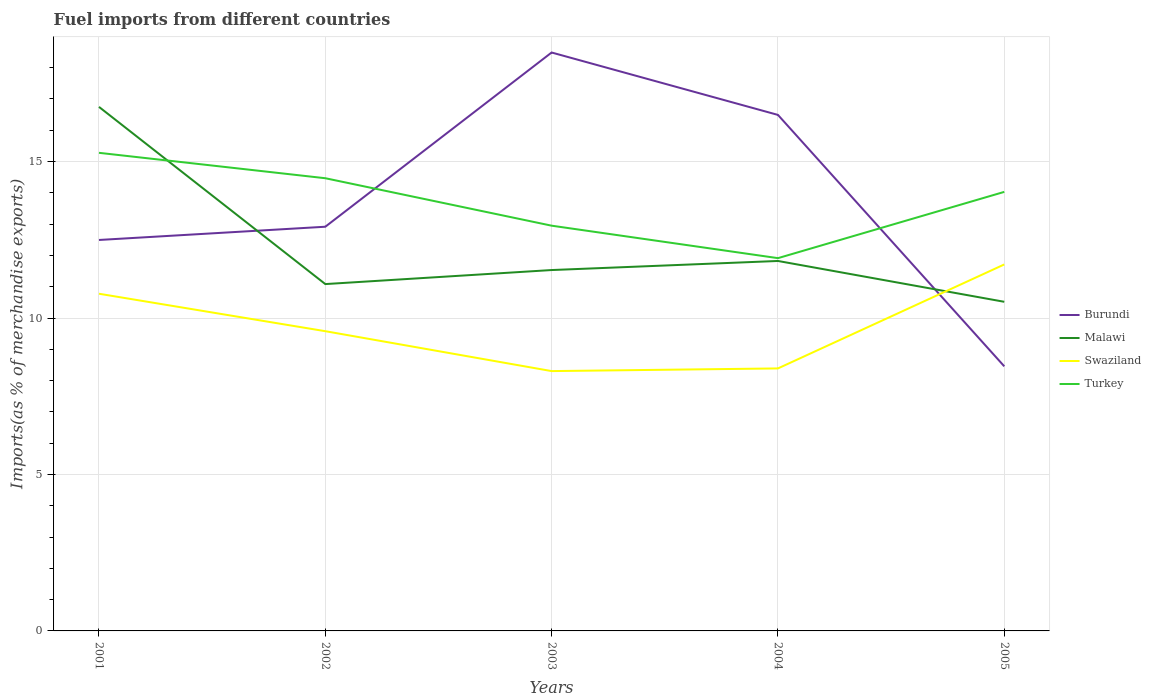How many different coloured lines are there?
Make the answer very short. 4. Is the number of lines equal to the number of legend labels?
Ensure brevity in your answer.  Yes. Across all years, what is the maximum percentage of imports to different countries in Malawi?
Your answer should be very brief. 10.52. In which year was the percentage of imports to different countries in Burundi maximum?
Make the answer very short. 2005. What is the total percentage of imports to different countries in Turkey in the graph?
Your answer should be compact. 1.25. What is the difference between the highest and the second highest percentage of imports to different countries in Burundi?
Make the answer very short. 10.03. Is the percentage of imports to different countries in Swaziland strictly greater than the percentage of imports to different countries in Turkey over the years?
Make the answer very short. Yes. How many lines are there?
Your answer should be compact. 4. How many years are there in the graph?
Your answer should be compact. 5. How are the legend labels stacked?
Offer a very short reply. Vertical. What is the title of the graph?
Your answer should be very brief. Fuel imports from different countries. What is the label or title of the X-axis?
Ensure brevity in your answer.  Years. What is the label or title of the Y-axis?
Give a very brief answer. Imports(as % of merchandise exports). What is the Imports(as % of merchandise exports) of Burundi in 2001?
Provide a short and direct response. 12.49. What is the Imports(as % of merchandise exports) of Malawi in 2001?
Keep it short and to the point. 16.75. What is the Imports(as % of merchandise exports) in Swaziland in 2001?
Ensure brevity in your answer.  10.78. What is the Imports(as % of merchandise exports) in Turkey in 2001?
Offer a terse response. 15.28. What is the Imports(as % of merchandise exports) in Burundi in 2002?
Offer a very short reply. 12.92. What is the Imports(as % of merchandise exports) in Malawi in 2002?
Offer a terse response. 11.08. What is the Imports(as % of merchandise exports) of Swaziland in 2002?
Provide a succinct answer. 9.58. What is the Imports(as % of merchandise exports) of Turkey in 2002?
Provide a short and direct response. 14.47. What is the Imports(as % of merchandise exports) of Burundi in 2003?
Keep it short and to the point. 18.48. What is the Imports(as % of merchandise exports) of Malawi in 2003?
Your answer should be compact. 11.53. What is the Imports(as % of merchandise exports) of Swaziland in 2003?
Your answer should be very brief. 8.3. What is the Imports(as % of merchandise exports) in Turkey in 2003?
Ensure brevity in your answer.  12.95. What is the Imports(as % of merchandise exports) of Burundi in 2004?
Provide a short and direct response. 16.49. What is the Imports(as % of merchandise exports) in Malawi in 2004?
Your answer should be compact. 11.82. What is the Imports(as % of merchandise exports) in Swaziland in 2004?
Your answer should be very brief. 8.39. What is the Imports(as % of merchandise exports) in Turkey in 2004?
Your answer should be very brief. 11.91. What is the Imports(as % of merchandise exports) of Burundi in 2005?
Keep it short and to the point. 8.46. What is the Imports(as % of merchandise exports) in Malawi in 2005?
Your response must be concise. 10.52. What is the Imports(as % of merchandise exports) in Swaziland in 2005?
Provide a succinct answer. 11.71. What is the Imports(as % of merchandise exports) in Turkey in 2005?
Offer a very short reply. 14.03. Across all years, what is the maximum Imports(as % of merchandise exports) in Burundi?
Give a very brief answer. 18.48. Across all years, what is the maximum Imports(as % of merchandise exports) in Malawi?
Your answer should be very brief. 16.75. Across all years, what is the maximum Imports(as % of merchandise exports) in Swaziland?
Provide a short and direct response. 11.71. Across all years, what is the maximum Imports(as % of merchandise exports) of Turkey?
Your answer should be compact. 15.28. Across all years, what is the minimum Imports(as % of merchandise exports) of Burundi?
Offer a very short reply. 8.46. Across all years, what is the minimum Imports(as % of merchandise exports) of Malawi?
Provide a succinct answer. 10.52. Across all years, what is the minimum Imports(as % of merchandise exports) of Swaziland?
Give a very brief answer. 8.3. Across all years, what is the minimum Imports(as % of merchandise exports) of Turkey?
Offer a terse response. 11.91. What is the total Imports(as % of merchandise exports) of Burundi in the graph?
Provide a short and direct response. 68.84. What is the total Imports(as % of merchandise exports) of Malawi in the graph?
Your answer should be compact. 61.7. What is the total Imports(as % of merchandise exports) of Swaziland in the graph?
Your answer should be very brief. 48.76. What is the total Imports(as % of merchandise exports) in Turkey in the graph?
Make the answer very short. 68.64. What is the difference between the Imports(as % of merchandise exports) of Burundi in 2001 and that in 2002?
Your answer should be compact. -0.42. What is the difference between the Imports(as % of merchandise exports) of Malawi in 2001 and that in 2002?
Give a very brief answer. 5.66. What is the difference between the Imports(as % of merchandise exports) in Swaziland in 2001 and that in 2002?
Ensure brevity in your answer.  1.2. What is the difference between the Imports(as % of merchandise exports) in Turkey in 2001 and that in 2002?
Your answer should be compact. 0.81. What is the difference between the Imports(as % of merchandise exports) of Burundi in 2001 and that in 2003?
Offer a terse response. -5.99. What is the difference between the Imports(as % of merchandise exports) in Malawi in 2001 and that in 2003?
Offer a very short reply. 5.21. What is the difference between the Imports(as % of merchandise exports) in Swaziland in 2001 and that in 2003?
Your answer should be very brief. 2.47. What is the difference between the Imports(as % of merchandise exports) of Turkey in 2001 and that in 2003?
Keep it short and to the point. 2.33. What is the difference between the Imports(as % of merchandise exports) of Burundi in 2001 and that in 2004?
Offer a terse response. -4. What is the difference between the Imports(as % of merchandise exports) in Malawi in 2001 and that in 2004?
Keep it short and to the point. 4.92. What is the difference between the Imports(as % of merchandise exports) in Swaziland in 2001 and that in 2004?
Give a very brief answer. 2.39. What is the difference between the Imports(as % of merchandise exports) in Turkey in 2001 and that in 2004?
Offer a terse response. 3.37. What is the difference between the Imports(as % of merchandise exports) of Burundi in 2001 and that in 2005?
Make the answer very short. 4.04. What is the difference between the Imports(as % of merchandise exports) of Malawi in 2001 and that in 2005?
Your answer should be very brief. 6.23. What is the difference between the Imports(as % of merchandise exports) of Swaziland in 2001 and that in 2005?
Your answer should be very brief. -0.94. What is the difference between the Imports(as % of merchandise exports) of Turkey in 2001 and that in 2005?
Make the answer very short. 1.25. What is the difference between the Imports(as % of merchandise exports) of Burundi in 2002 and that in 2003?
Give a very brief answer. -5.57. What is the difference between the Imports(as % of merchandise exports) in Malawi in 2002 and that in 2003?
Provide a succinct answer. -0.45. What is the difference between the Imports(as % of merchandise exports) of Swaziland in 2002 and that in 2003?
Your response must be concise. 1.28. What is the difference between the Imports(as % of merchandise exports) of Turkey in 2002 and that in 2003?
Make the answer very short. 1.52. What is the difference between the Imports(as % of merchandise exports) of Burundi in 2002 and that in 2004?
Provide a short and direct response. -3.57. What is the difference between the Imports(as % of merchandise exports) of Malawi in 2002 and that in 2004?
Make the answer very short. -0.74. What is the difference between the Imports(as % of merchandise exports) of Swaziland in 2002 and that in 2004?
Ensure brevity in your answer.  1.19. What is the difference between the Imports(as % of merchandise exports) in Turkey in 2002 and that in 2004?
Your answer should be very brief. 2.55. What is the difference between the Imports(as % of merchandise exports) in Burundi in 2002 and that in 2005?
Ensure brevity in your answer.  4.46. What is the difference between the Imports(as % of merchandise exports) of Malawi in 2002 and that in 2005?
Your answer should be very brief. 0.57. What is the difference between the Imports(as % of merchandise exports) in Swaziland in 2002 and that in 2005?
Make the answer very short. -2.13. What is the difference between the Imports(as % of merchandise exports) of Turkey in 2002 and that in 2005?
Offer a terse response. 0.44. What is the difference between the Imports(as % of merchandise exports) in Burundi in 2003 and that in 2004?
Make the answer very short. 1.99. What is the difference between the Imports(as % of merchandise exports) of Malawi in 2003 and that in 2004?
Your response must be concise. -0.29. What is the difference between the Imports(as % of merchandise exports) in Swaziland in 2003 and that in 2004?
Your response must be concise. -0.09. What is the difference between the Imports(as % of merchandise exports) of Turkey in 2003 and that in 2004?
Your answer should be compact. 1.04. What is the difference between the Imports(as % of merchandise exports) in Burundi in 2003 and that in 2005?
Offer a terse response. 10.03. What is the difference between the Imports(as % of merchandise exports) in Malawi in 2003 and that in 2005?
Offer a terse response. 1.01. What is the difference between the Imports(as % of merchandise exports) of Swaziland in 2003 and that in 2005?
Provide a short and direct response. -3.41. What is the difference between the Imports(as % of merchandise exports) of Turkey in 2003 and that in 2005?
Provide a succinct answer. -1.08. What is the difference between the Imports(as % of merchandise exports) of Burundi in 2004 and that in 2005?
Your response must be concise. 8.03. What is the difference between the Imports(as % of merchandise exports) in Malawi in 2004 and that in 2005?
Your response must be concise. 1.3. What is the difference between the Imports(as % of merchandise exports) of Swaziland in 2004 and that in 2005?
Your response must be concise. -3.32. What is the difference between the Imports(as % of merchandise exports) of Turkey in 2004 and that in 2005?
Provide a short and direct response. -2.12. What is the difference between the Imports(as % of merchandise exports) in Burundi in 2001 and the Imports(as % of merchandise exports) in Malawi in 2002?
Offer a terse response. 1.41. What is the difference between the Imports(as % of merchandise exports) in Burundi in 2001 and the Imports(as % of merchandise exports) in Swaziland in 2002?
Your answer should be compact. 2.92. What is the difference between the Imports(as % of merchandise exports) of Burundi in 2001 and the Imports(as % of merchandise exports) of Turkey in 2002?
Offer a terse response. -1.97. What is the difference between the Imports(as % of merchandise exports) of Malawi in 2001 and the Imports(as % of merchandise exports) of Swaziland in 2002?
Make the answer very short. 7.17. What is the difference between the Imports(as % of merchandise exports) of Malawi in 2001 and the Imports(as % of merchandise exports) of Turkey in 2002?
Offer a terse response. 2.28. What is the difference between the Imports(as % of merchandise exports) of Swaziland in 2001 and the Imports(as % of merchandise exports) of Turkey in 2002?
Your response must be concise. -3.69. What is the difference between the Imports(as % of merchandise exports) in Burundi in 2001 and the Imports(as % of merchandise exports) in Malawi in 2003?
Keep it short and to the point. 0.96. What is the difference between the Imports(as % of merchandise exports) of Burundi in 2001 and the Imports(as % of merchandise exports) of Swaziland in 2003?
Your answer should be very brief. 4.19. What is the difference between the Imports(as % of merchandise exports) of Burundi in 2001 and the Imports(as % of merchandise exports) of Turkey in 2003?
Offer a terse response. -0.46. What is the difference between the Imports(as % of merchandise exports) in Malawi in 2001 and the Imports(as % of merchandise exports) in Swaziland in 2003?
Make the answer very short. 8.44. What is the difference between the Imports(as % of merchandise exports) in Malawi in 2001 and the Imports(as % of merchandise exports) in Turkey in 2003?
Your response must be concise. 3.8. What is the difference between the Imports(as % of merchandise exports) in Swaziland in 2001 and the Imports(as % of merchandise exports) in Turkey in 2003?
Your answer should be compact. -2.17. What is the difference between the Imports(as % of merchandise exports) in Burundi in 2001 and the Imports(as % of merchandise exports) in Malawi in 2004?
Offer a terse response. 0.67. What is the difference between the Imports(as % of merchandise exports) of Burundi in 2001 and the Imports(as % of merchandise exports) of Swaziland in 2004?
Provide a short and direct response. 4.11. What is the difference between the Imports(as % of merchandise exports) of Burundi in 2001 and the Imports(as % of merchandise exports) of Turkey in 2004?
Give a very brief answer. 0.58. What is the difference between the Imports(as % of merchandise exports) in Malawi in 2001 and the Imports(as % of merchandise exports) in Swaziland in 2004?
Your answer should be very brief. 8.36. What is the difference between the Imports(as % of merchandise exports) in Malawi in 2001 and the Imports(as % of merchandise exports) in Turkey in 2004?
Offer a terse response. 4.83. What is the difference between the Imports(as % of merchandise exports) of Swaziland in 2001 and the Imports(as % of merchandise exports) of Turkey in 2004?
Provide a succinct answer. -1.14. What is the difference between the Imports(as % of merchandise exports) of Burundi in 2001 and the Imports(as % of merchandise exports) of Malawi in 2005?
Offer a terse response. 1.98. What is the difference between the Imports(as % of merchandise exports) of Burundi in 2001 and the Imports(as % of merchandise exports) of Swaziland in 2005?
Your response must be concise. 0.78. What is the difference between the Imports(as % of merchandise exports) in Burundi in 2001 and the Imports(as % of merchandise exports) in Turkey in 2005?
Your answer should be compact. -1.54. What is the difference between the Imports(as % of merchandise exports) of Malawi in 2001 and the Imports(as % of merchandise exports) of Swaziland in 2005?
Offer a very short reply. 5.04. What is the difference between the Imports(as % of merchandise exports) of Malawi in 2001 and the Imports(as % of merchandise exports) of Turkey in 2005?
Provide a short and direct response. 2.72. What is the difference between the Imports(as % of merchandise exports) of Swaziland in 2001 and the Imports(as % of merchandise exports) of Turkey in 2005?
Your response must be concise. -3.26. What is the difference between the Imports(as % of merchandise exports) in Burundi in 2002 and the Imports(as % of merchandise exports) in Malawi in 2003?
Make the answer very short. 1.38. What is the difference between the Imports(as % of merchandise exports) in Burundi in 2002 and the Imports(as % of merchandise exports) in Swaziland in 2003?
Offer a terse response. 4.61. What is the difference between the Imports(as % of merchandise exports) of Burundi in 2002 and the Imports(as % of merchandise exports) of Turkey in 2003?
Ensure brevity in your answer.  -0.03. What is the difference between the Imports(as % of merchandise exports) of Malawi in 2002 and the Imports(as % of merchandise exports) of Swaziland in 2003?
Your answer should be compact. 2.78. What is the difference between the Imports(as % of merchandise exports) of Malawi in 2002 and the Imports(as % of merchandise exports) of Turkey in 2003?
Offer a very short reply. -1.87. What is the difference between the Imports(as % of merchandise exports) in Swaziland in 2002 and the Imports(as % of merchandise exports) in Turkey in 2003?
Make the answer very short. -3.37. What is the difference between the Imports(as % of merchandise exports) in Burundi in 2002 and the Imports(as % of merchandise exports) in Malawi in 2004?
Keep it short and to the point. 1.09. What is the difference between the Imports(as % of merchandise exports) in Burundi in 2002 and the Imports(as % of merchandise exports) in Swaziland in 2004?
Offer a very short reply. 4.53. What is the difference between the Imports(as % of merchandise exports) in Burundi in 2002 and the Imports(as % of merchandise exports) in Turkey in 2004?
Provide a short and direct response. 1. What is the difference between the Imports(as % of merchandise exports) of Malawi in 2002 and the Imports(as % of merchandise exports) of Swaziland in 2004?
Ensure brevity in your answer.  2.7. What is the difference between the Imports(as % of merchandise exports) of Malawi in 2002 and the Imports(as % of merchandise exports) of Turkey in 2004?
Keep it short and to the point. -0.83. What is the difference between the Imports(as % of merchandise exports) in Swaziland in 2002 and the Imports(as % of merchandise exports) in Turkey in 2004?
Provide a succinct answer. -2.33. What is the difference between the Imports(as % of merchandise exports) of Burundi in 2002 and the Imports(as % of merchandise exports) of Malawi in 2005?
Keep it short and to the point. 2.4. What is the difference between the Imports(as % of merchandise exports) of Burundi in 2002 and the Imports(as % of merchandise exports) of Swaziland in 2005?
Provide a succinct answer. 1.21. What is the difference between the Imports(as % of merchandise exports) of Burundi in 2002 and the Imports(as % of merchandise exports) of Turkey in 2005?
Ensure brevity in your answer.  -1.11. What is the difference between the Imports(as % of merchandise exports) of Malawi in 2002 and the Imports(as % of merchandise exports) of Swaziland in 2005?
Give a very brief answer. -0.63. What is the difference between the Imports(as % of merchandise exports) of Malawi in 2002 and the Imports(as % of merchandise exports) of Turkey in 2005?
Make the answer very short. -2.95. What is the difference between the Imports(as % of merchandise exports) in Swaziland in 2002 and the Imports(as % of merchandise exports) in Turkey in 2005?
Your response must be concise. -4.45. What is the difference between the Imports(as % of merchandise exports) in Burundi in 2003 and the Imports(as % of merchandise exports) in Malawi in 2004?
Ensure brevity in your answer.  6.66. What is the difference between the Imports(as % of merchandise exports) in Burundi in 2003 and the Imports(as % of merchandise exports) in Swaziland in 2004?
Keep it short and to the point. 10.1. What is the difference between the Imports(as % of merchandise exports) in Burundi in 2003 and the Imports(as % of merchandise exports) in Turkey in 2004?
Keep it short and to the point. 6.57. What is the difference between the Imports(as % of merchandise exports) in Malawi in 2003 and the Imports(as % of merchandise exports) in Swaziland in 2004?
Give a very brief answer. 3.14. What is the difference between the Imports(as % of merchandise exports) of Malawi in 2003 and the Imports(as % of merchandise exports) of Turkey in 2004?
Ensure brevity in your answer.  -0.38. What is the difference between the Imports(as % of merchandise exports) in Swaziland in 2003 and the Imports(as % of merchandise exports) in Turkey in 2004?
Offer a terse response. -3.61. What is the difference between the Imports(as % of merchandise exports) of Burundi in 2003 and the Imports(as % of merchandise exports) of Malawi in 2005?
Provide a succinct answer. 7.97. What is the difference between the Imports(as % of merchandise exports) in Burundi in 2003 and the Imports(as % of merchandise exports) in Swaziland in 2005?
Your answer should be compact. 6.77. What is the difference between the Imports(as % of merchandise exports) in Burundi in 2003 and the Imports(as % of merchandise exports) in Turkey in 2005?
Offer a very short reply. 4.45. What is the difference between the Imports(as % of merchandise exports) of Malawi in 2003 and the Imports(as % of merchandise exports) of Swaziland in 2005?
Your answer should be very brief. -0.18. What is the difference between the Imports(as % of merchandise exports) of Malawi in 2003 and the Imports(as % of merchandise exports) of Turkey in 2005?
Offer a very short reply. -2.5. What is the difference between the Imports(as % of merchandise exports) in Swaziland in 2003 and the Imports(as % of merchandise exports) in Turkey in 2005?
Keep it short and to the point. -5.73. What is the difference between the Imports(as % of merchandise exports) of Burundi in 2004 and the Imports(as % of merchandise exports) of Malawi in 2005?
Ensure brevity in your answer.  5.97. What is the difference between the Imports(as % of merchandise exports) in Burundi in 2004 and the Imports(as % of merchandise exports) in Swaziland in 2005?
Keep it short and to the point. 4.78. What is the difference between the Imports(as % of merchandise exports) of Burundi in 2004 and the Imports(as % of merchandise exports) of Turkey in 2005?
Provide a short and direct response. 2.46. What is the difference between the Imports(as % of merchandise exports) in Malawi in 2004 and the Imports(as % of merchandise exports) in Swaziland in 2005?
Ensure brevity in your answer.  0.11. What is the difference between the Imports(as % of merchandise exports) in Malawi in 2004 and the Imports(as % of merchandise exports) in Turkey in 2005?
Give a very brief answer. -2.21. What is the difference between the Imports(as % of merchandise exports) in Swaziland in 2004 and the Imports(as % of merchandise exports) in Turkey in 2005?
Provide a succinct answer. -5.64. What is the average Imports(as % of merchandise exports) in Burundi per year?
Keep it short and to the point. 13.77. What is the average Imports(as % of merchandise exports) in Malawi per year?
Offer a terse response. 12.34. What is the average Imports(as % of merchandise exports) of Swaziland per year?
Offer a terse response. 9.75. What is the average Imports(as % of merchandise exports) of Turkey per year?
Give a very brief answer. 13.73. In the year 2001, what is the difference between the Imports(as % of merchandise exports) in Burundi and Imports(as % of merchandise exports) in Malawi?
Your answer should be very brief. -4.25. In the year 2001, what is the difference between the Imports(as % of merchandise exports) in Burundi and Imports(as % of merchandise exports) in Swaziland?
Your answer should be very brief. 1.72. In the year 2001, what is the difference between the Imports(as % of merchandise exports) of Burundi and Imports(as % of merchandise exports) of Turkey?
Ensure brevity in your answer.  -2.78. In the year 2001, what is the difference between the Imports(as % of merchandise exports) in Malawi and Imports(as % of merchandise exports) in Swaziland?
Keep it short and to the point. 5.97. In the year 2001, what is the difference between the Imports(as % of merchandise exports) in Malawi and Imports(as % of merchandise exports) in Turkey?
Ensure brevity in your answer.  1.47. In the year 2001, what is the difference between the Imports(as % of merchandise exports) in Swaziland and Imports(as % of merchandise exports) in Turkey?
Give a very brief answer. -4.5. In the year 2002, what is the difference between the Imports(as % of merchandise exports) of Burundi and Imports(as % of merchandise exports) of Malawi?
Your answer should be very brief. 1.83. In the year 2002, what is the difference between the Imports(as % of merchandise exports) of Burundi and Imports(as % of merchandise exports) of Swaziland?
Provide a short and direct response. 3.34. In the year 2002, what is the difference between the Imports(as % of merchandise exports) of Burundi and Imports(as % of merchandise exports) of Turkey?
Your answer should be compact. -1.55. In the year 2002, what is the difference between the Imports(as % of merchandise exports) in Malawi and Imports(as % of merchandise exports) in Swaziland?
Give a very brief answer. 1.51. In the year 2002, what is the difference between the Imports(as % of merchandise exports) of Malawi and Imports(as % of merchandise exports) of Turkey?
Your answer should be very brief. -3.38. In the year 2002, what is the difference between the Imports(as % of merchandise exports) in Swaziland and Imports(as % of merchandise exports) in Turkey?
Make the answer very short. -4.89. In the year 2003, what is the difference between the Imports(as % of merchandise exports) in Burundi and Imports(as % of merchandise exports) in Malawi?
Give a very brief answer. 6.95. In the year 2003, what is the difference between the Imports(as % of merchandise exports) of Burundi and Imports(as % of merchandise exports) of Swaziland?
Your response must be concise. 10.18. In the year 2003, what is the difference between the Imports(as % of merchandise exports) in Burundi and Imports(as % of merchandise exports) in Turkey?
Keep it short and to the point. 5.53. In the year 2003, what is the difference between the Imports(as % of merchandise exports) of Malawi and Imports(as % of merchandise exports) of Swaziland?
Offer a very short reply. 3.23. In the year 2003, what is the difference between the Imports(as % of merchandise exports) in Malawi and Imports(as % of merchandise exports) in Turkey?
Ensure brevity in your answer.  -1.42. In the year 2003, what is the difference between the Imports(as % of merchandise exports) of Swaziland and Imports(as % of merchandise exports) of Turkey?
Make the answer very short. -4.65. In the year 2004, what is the difference between the Imports(as % of merchandise exports) in Burundi and Imports(as % of merchandise exports) in Malawi?
Make the answer very short. 4.67. In the year 2004, what is the difference between the Imports(as % of merchandise exports) of Burundi and Imports(as % of merchandise exports) of Swaziland?
Your answer should be very brief. 8.1. In the year 2004, what is the difference between the Imports(as % of merchandise exports) of Burundi and Imports(as % of merchandise exports) of Turkey?
Offer a terse response. 4.58. In the year 2004, what is the difference between the Imports(as % of merchandise exports) in Malawi and Imports(as % of merchandise exports) in Swaziland?
Make the answer very short. 3.43. In the year 2004, what is the difference between the Imports(as % of merchandise exports) of Malawi and Imports(as % of merchandise exports) of Turkey?
Keep it short and to the point. -0.09. In the year 2004, what is the difference between the Imports(as % of merchandise exports) in Swaziland and Imports(as % of merchandise exports) in Turkey?
Your response must be concise. -3.52. In the year 2005, what is the difference between the Imports(as % of merchandise exports) in Burundi and Imports(as % of merchandise exports) in Malawi?
Your answer should be compact. -2.06. In the year 2005, what is the difference between the Imports(as % of merchandise exports) of Burundi and Imports(as % of merchandise exports) of Swaziland?
Your response must be concise. -3.26. In the year 2005, what is the difference between the Imports(as % of merchandise exports) in Burundi and Imports(as % of merchandise exports) in Turkey?
Provide a short and direct response. -5.58. In the year 2005, what is the difference between the Imports(as % of merchandise exports) of Malawi and Imports(as % of merchandise exports) of Swaziland?
Make the answer very short. -1.19. In the year 2005, what is the difference between the Imports(as % of merchandise exports) in Malawi and Imports(as % of merchandise exports) in Turkey?
Provide a succinct answer. -3.51. In the year 2005, what is the difference between the Imports(as % of merchandise exports) of Swaziland and Imports(as % of merchandise exports) of Turkey?
Keep it short and to the point. -2.32. What is the ratio of the Imports(as % of merchandise exports) of Burundi in 2001 to that in 2002?
Ensure brevity in your answer.  0.97. What is the ratio of the Imports(as % of merchandise exports) in Malawi in 2001 to that in 2002?
Your answer should be very brief. 1.51. What is the ratio of the Imports(as % of merchandise exports) in Swaziland in 2001 to that in 2002?
Give a very brief answer. 1.12. What is the ratio of the Imports(as % of merchandise exports) in Turkey in 2001 to that in 2002?
Provide a short and direct response. 1.06. What is the ratio of the Imports(as % of merchandise exports) of Burundi in 2001 to that in 2003?
Provide a succinct answer. 0.68. What is the ratio of the Imports(as % of merchandise exports) of Malawi in 2001 to that in 2003?
Provide a short and direct response. 1.45. What is the ratio of the Imports(as % of merchandise exports) in Swaziland in 2001 to that in 2003?
Your response must be concise. 1.3. What is the ratio of the Imports(as % of merchandise exports) of Turkey in 2001 to that in 2003?
Offer a terse response. 1.18. What is the ratio of the Imports(as % of merchandise exports) in Burundi in 2001 to that in 2004?
Ensure brevity in your answer.  0.76. What is the ratio of the Imports(as % of merchandise exports) in Malawi in 2001 to that in 2004?
Give a very brief answer. 1.42. What is the ratio of the Imports(as % of merchandise exports) in Swaziland in 2001 to that in 2004?
Offer a very short reply. 1.28. What is the ratio of the Imports(as % of merchandise exports) of Turkey in 2001 to that in 2004?
Your answer should be very brief. 1.28. What is the ratio of the Imports(as % of merchandise exports) of Burundi in 2001 to that in 2005?
Make the answer very short. 1.48. What is the ratio of the Imports(as % of merchandise exports) in Malawi in 2001 to that in 2005?
Offer a terse response. 1.59. What is the ratio of the Imports(as % of merchandise exports) in Swaziland in 2001 to that in 2005?
Give a very brief answer. 0.92. What is the ratio of the Imports(as % of merchandise exports) in Turkey in 2001 to that in 2005?
Make the answer very short. 1.09. What is the ratio of the Imports(as % of merchandise exports) of Burundi in 2002 to that in 2003?
Offer a very short reply. 0.7. What is the ratio of the Imports(as % of merchandise exports) of Malawi in 2002 to that in 2003?
Offer a very short reply. 0.96. What is the ratio of the Imports(as % of merchandise exports) in Swaziland in 2002 to that in 2003?
Provide a succinct answer. 1.15. What is the ratio of the Imports(as % of merchandise exports) of Turkey in 2002 to that in 2003?
Make the answer very short. 1.12. What is the ratio of the Imports(as % of merchandise exports) in Burundi in 2002 to that in 2004?
Offer a terse response. 0.78. What is the ratio of the Imports(as % of merchandise exports) of Malawi in 2002 to that in 2004?
Make the answer very short. 0.94. What is the ratio of the Imports(as % of merchandise exports) of Swaziland in 2002 to that in 2004?
Your response must be concise. 1.14. What is the ratio of the Imports(as % of merchandise exports) of Turkey in 2002 to that in 2004?
Make the answer very short. 1.21. What is the ratio of the Imports(as % of merchandise exports) in Burundi in 2002 to that in 2005?
Give a very brief answer. 1.53. What is the ratio of the Imports(as % of merchandise exports) of Malawi in 2002 to that in 2005?
Offer a very short reply. 1.05. What is the ratio of the Imports(as % of merchandise exports) of Swaziland in 2002 to that in 2005?
Keep it short and to the point. 0.82. What is the ratio of the Imports(as % of merchandise exports) of Turkey in 2002 to that in 2005?
Make the answer very short. 1.03. What is the ratio of the Imports(as % of merchandise exports) of Burundi in 2003 to that in 2004?
Your answer should be very brief. 1.12. What is the ratio of the Imports(as % of merchandise exports) in Malawi in 2003 to that in 2004?
Offer a very short reply. 0.98. What is the ratio of the Imports(as % of merchandise exports) in Turkey in 2003 to that in 2004?
Your answer should be very brief. 1.09. What is the ratio of the Imports(as % of merchandise exports) in Burundi in 2003 to that in 2005?
Keep it short and to the point. 2.19. What is the ratio of the Imports(as % of merchandise exports) of Malawi in 2003 to that in 2005?
Offer a very short reply. 1.1. What is the ratio of the Imports(as % of merchandise exports) of Swaziland in 2003 to that in 2005?
Your answer should be compact. 0.71. What is the ratio of the Imports(as % of merchandise exports) of Turkey in 2003 to that in 2005?
Your response must be concise. 0.92. What is the ratio of the Imports(as % of merchandise exports) of Burundi in 2004 to that in 2005?
Your response must be concise. 1.95. What is the ratio of the Imports(as % of merchandise exports) in Malawi in 2004 to that in 2005?
Make the answer very short. 1.12. What is the ratio of the Imports(as % of merchandise exports) of Swaziland in 2004 to that in 2005?
Provide a succinct answer. 0.72. What is the ratio of the Imports(as % of merchandise exports) in Turkey in 2004 to that in 2005?
Provide a short and direct response. 0.85. What is the difference between the highest and the second highest Imports(as % of merchandise exports) in Burundi?
Ensure brevity in your answer.  1.99. What is the difference between the highest and the second highest Imports(as % of merchandise exports) in Malawi?
Your answer should be compact. 4.92. What is the difference between the highest and the second highest Imports(as % of merchandise exports) of Swaziland?
Provide a succinct answer. 0.94. What is the difference between the highest and the second highest Imports(as % of merchandise exports) of Turkey?
Keep it short and to the point. 0.81. What is the difference between the highest and the lowest Imports(as % of merchandise exports) of Burundi?
Provide a short and direct response. 10.03. What is the difference between the highest and the lowest Imports(as % of merchandise exports) of Malawi?
Offer a terse response. 6.23. What is the difference between the highest and the lowest Imports(as % of merchandise exports) in Swaziland?
Offer a very short reply. 3.41. What is the difference between the highest and the lowest Imports(as % of merchandise exports) of Turkey?
Your answer should be very brief. 3.37. 